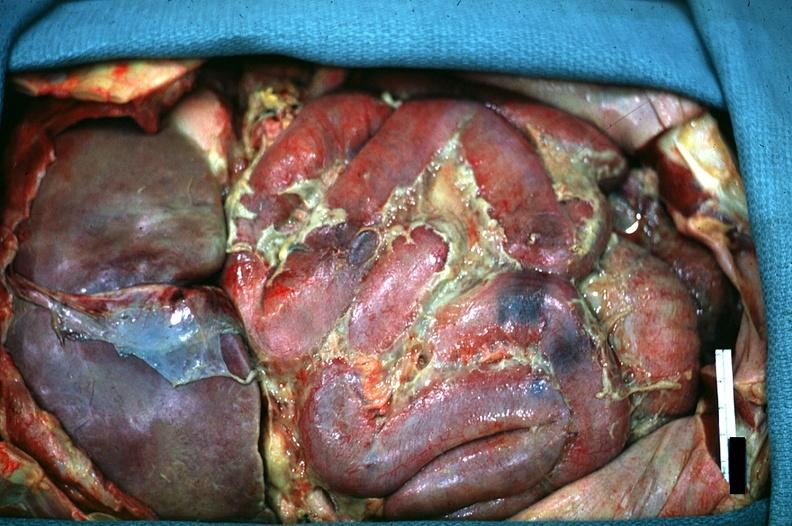does this image show in situ of abdomen excellent fibrinopurulent peritonitis?
Answer the question using a single word or phrase. Yes 